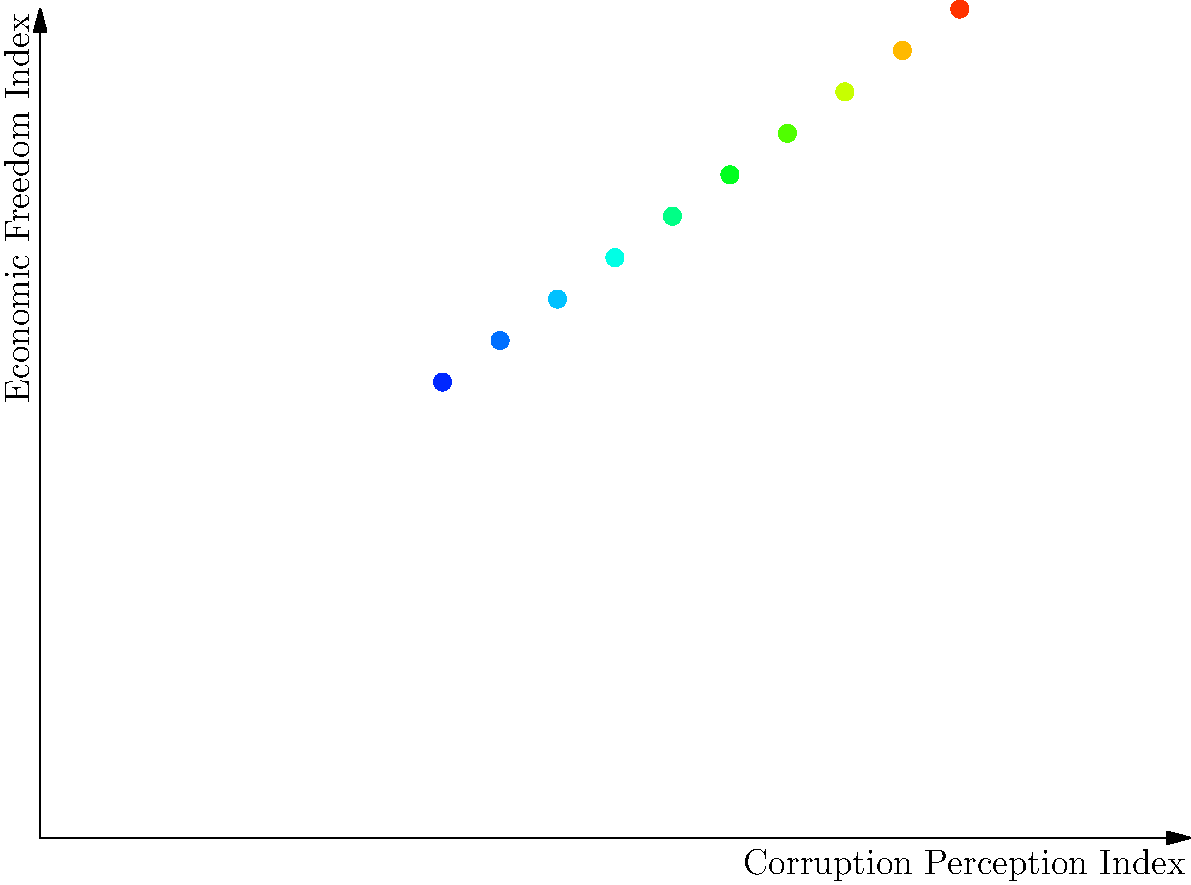Analyze the heat map depicting the relationship between the Corruption Perception Index (CPI) and the Economic Freedom Index (EFI). What does the color gradient suggest about the correlation between these two indices, and how might this relationship inform our understanding of the impact of political institutions on economic outcomes? To answer this question, we need to analyze the heat map step-by-step:

1. Interpret the axes:
   - X-axis represents the Corruption Perception Index (CPI)
   - Y-axis represents the Economic Freedom Index (EFI)

2. Understand the color gradient:
   - Darker colors (blue) indicate lower correlation
   - Lighter colors (red) indicate higher correlation

3. Observe the pattern:
   - There is a clear diagonal pattern from bottom-left to top-right
   - Colors transition from dark to light along this diagonal

4. Interpret the relationship:
   - As CPI increases (less perceived corruption), EFI tends to increase
   - As EFI increases, CPI tends to increase
   - This suggests a positive correlation between CPI and EFI

5. Connect to political institutions:
   - Political institutions that reduce corruption (higher CPI) are associated with greater economic freedom (higher EFI)
   - This supports the argument that political institutions have a significant influence on economic outcomes

6. Consider the implications:
   - Countries with stronger anti-corruption measures and more transparent political institutions may experience greater economic freedom
   - Improving political institutions could potentially lead to better economic outcomes

7. Limitations:
   - Correlation does not imply causation
   - Other factors not shown in this heat map may also influence the relationship

The heat map provides visual evidence of a positive relationship between political institutions (as measured by corruption perception) and economic outcomes (as measured by economic freedom). This supports the argument that political institutions have a substantial influence on economic performance.
Answer: The heat map suggests a strong positive correlation between CPI and EFI, supporting the argument that political institutions significantly influence economic outcomes by showing that countries with less perceived corruption tend to have greater economic freedom. 